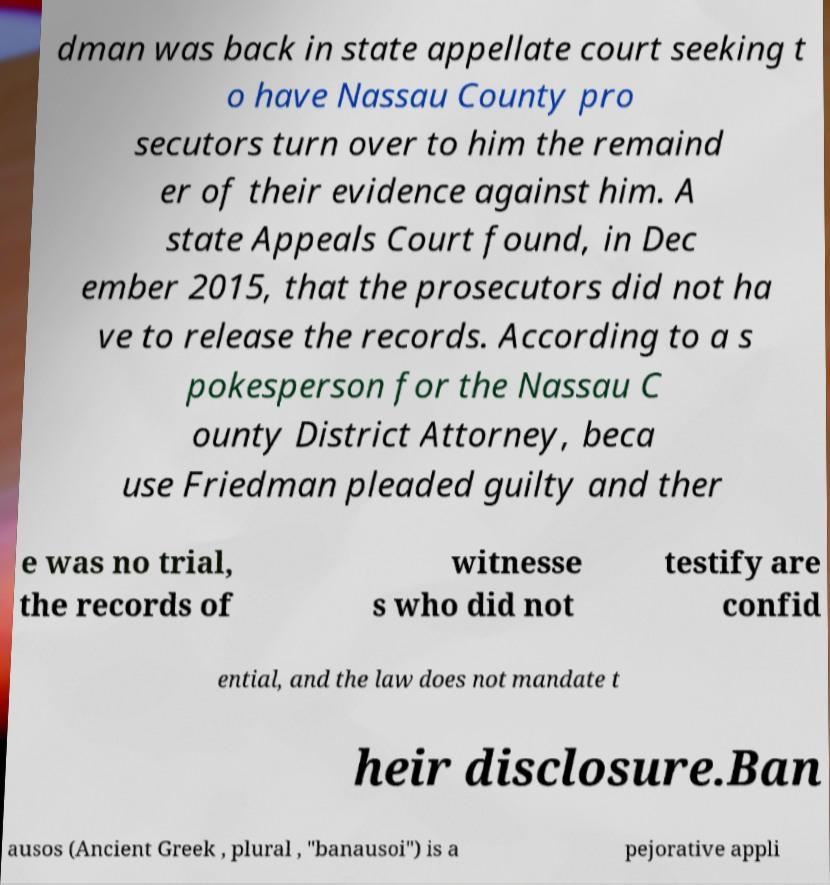For documentation purposes, I need the text within this image transcribed. Could you provide that? dman was back in state appellate court seeking t o have Nassau County pro secutors turn over to him the remaind er of their evidence against him. A state Appeals Court found, in Dec ember 2015, that the prosecutors did not ha ve to release the records. According to a s pokesperson for the Nassau C ounty District Attorney, beca use Friedman pleaded guilty and ther e was no trial, the records of witnesse s who did not testify are confid ential, and the law does not mandate t heir disclosure.Ban ausos (Ancient Greek , plural , "banausoi") is a pejorative appli 